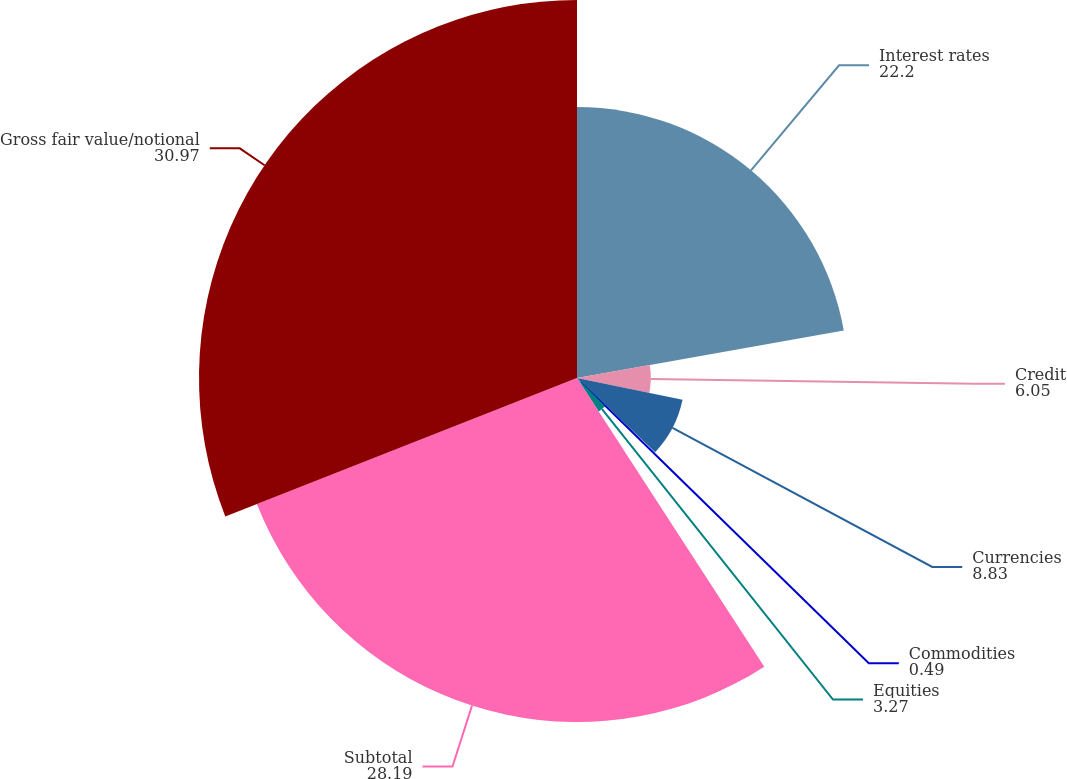Convert chart. <chart><loc_0><loc_0><loc_500><loc_500><pie_chart><fcel>Interest rates<fcel>Credit<fcel>Currencies<fcel>Commodities<fcel>Equities<fcel>Subtotal<fcel>Gross fair value/notional<nl><fcel>22.2%<fcel>6.05%<fcel>8.83%<fcel>0.49%<fcel>3.27%<fcel>28.19%<fcel>30.97%<nl></chart> 